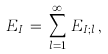<formula> <loc_0><loc_0><loc_500><loc_500>E _ { I } \, = \, \sum _ { l = 1 } ^ { \infty } \, E _ { I ; l } \, ,</formula> 